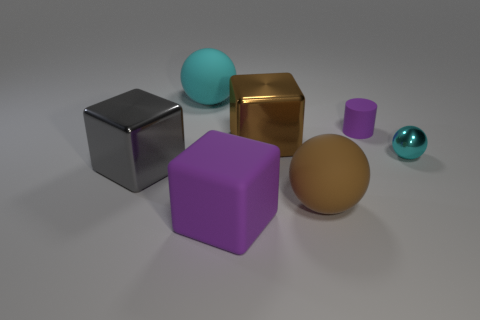Does the sphere that is in front of the big gray object have the same color as the big rubber block?
Provide a succinct answer. No. How many purple objects are behind the small metal ball?
Offer a terse response. 1. Do the big cyan object and the purple thing to the left of the brown block have the same material?
Offer a terse response. Yes. The purple cylinder that is the same material as the purple block is what size?
Your answer should be very brief. Small. Is the number of rubber cylinders behind the large cyan sphere greater than the number of cubes on the left side of the purple block?
Provide a short and direct response. No. Are there any tiny green things that have the same shape as the small cyan thing?
Provide a short and direct response. No. Is the size of the cyan ball that is in front of the brown shiny thing the same as the purple block?
Offer a terse response. No. Are there any large gray cubes?
Keep it short and to the point. Yes. What number of things are either purple objects that are behind the cyan shiny object or large brown matte blocks?
Offer a terse response. 1. Is the color of the small metal sphere the same as the large metallic cube in front of the big brown cube?
Give a very brief answer. No. 